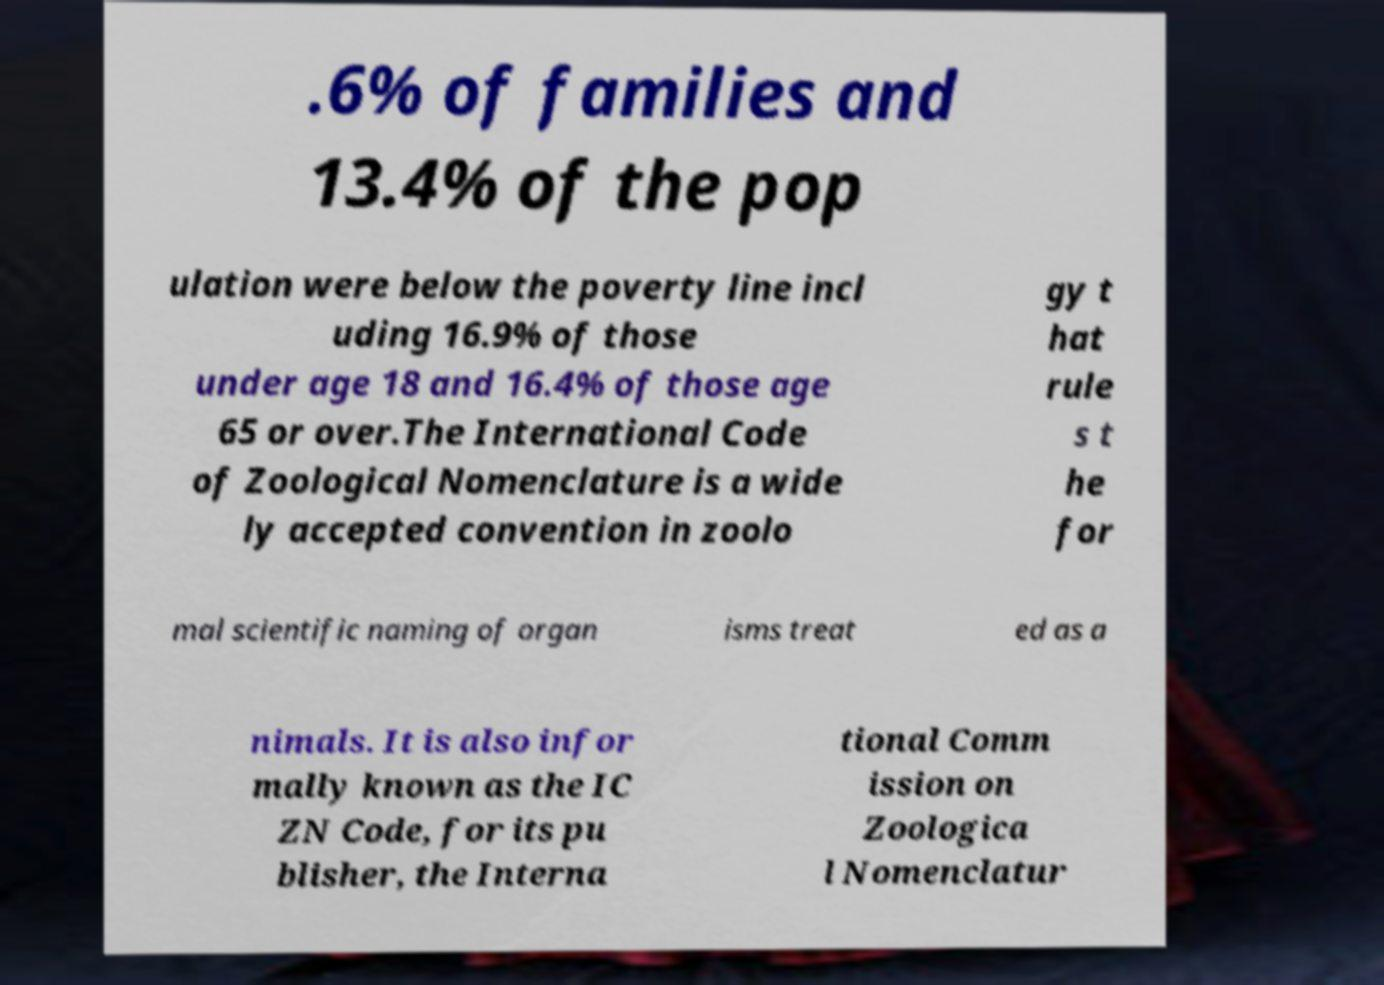Please identify and transcribe the text found in this image. .6% of families and 13.4% of the pop ulation were below the poverty line incl uding 16.9% of those under age 18 and 16.4% of those age 65 or over.The International Code of Zoological Nomenclature is a wide ly accepted convention in zoolo gy t hat rule s t he for mal scientific naming of organ isms treat ed as a nimals. It is also infor mally known as the IC ZN Code, for its pu blisher, the Interna tional Comm ission on Zoologica l Nomenclatur 